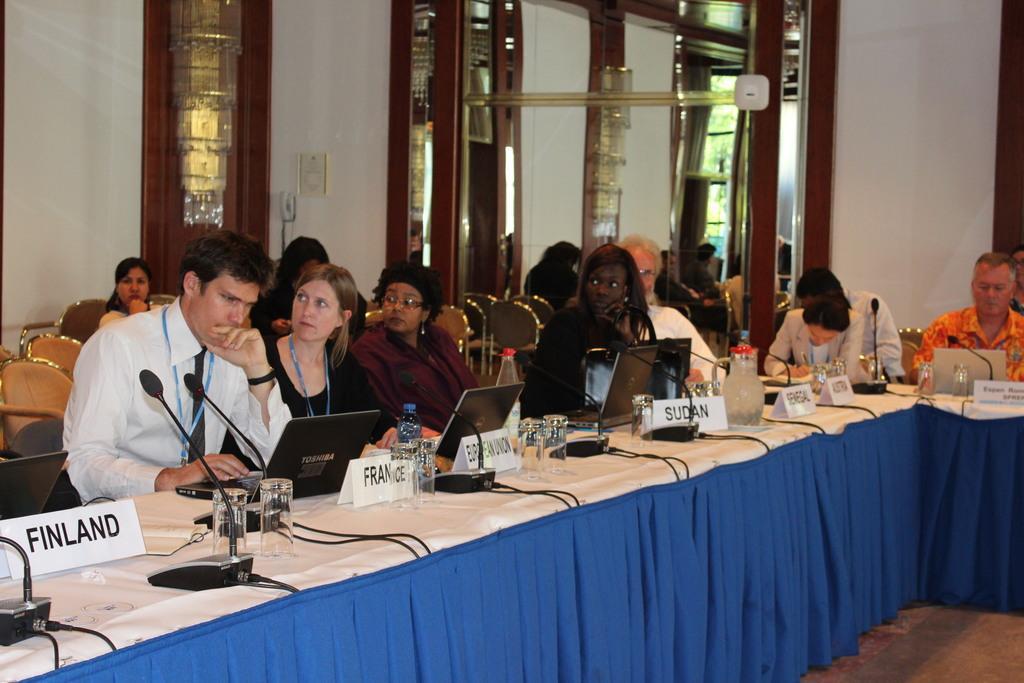Please provide a concise description of this image. In the image there are few people sitting in front of table with laptops,mic,glass,water bottles,water jug on it and behind them there are few people sitting on chairs, this seems to be clicked in a conference room, to the background wall there is a glass door and a chandelier on the left side. 